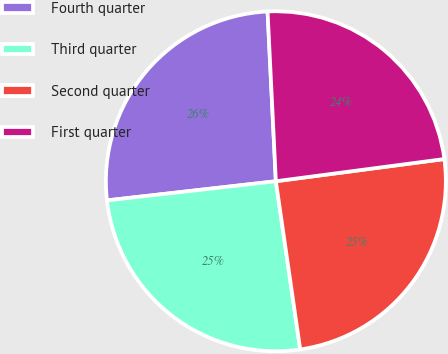Convert chart. <chart><loc_0><loc_0><loc_500><loc_500><pie_chart><fcel>Fourth quarter<fcel>Third quarter<fcel>Second quarter<fcel>First quarter<nl><fcel>26.02%<fcel>25.49%<fcel>24.8%<fcel>23.69%<nl></chart> 